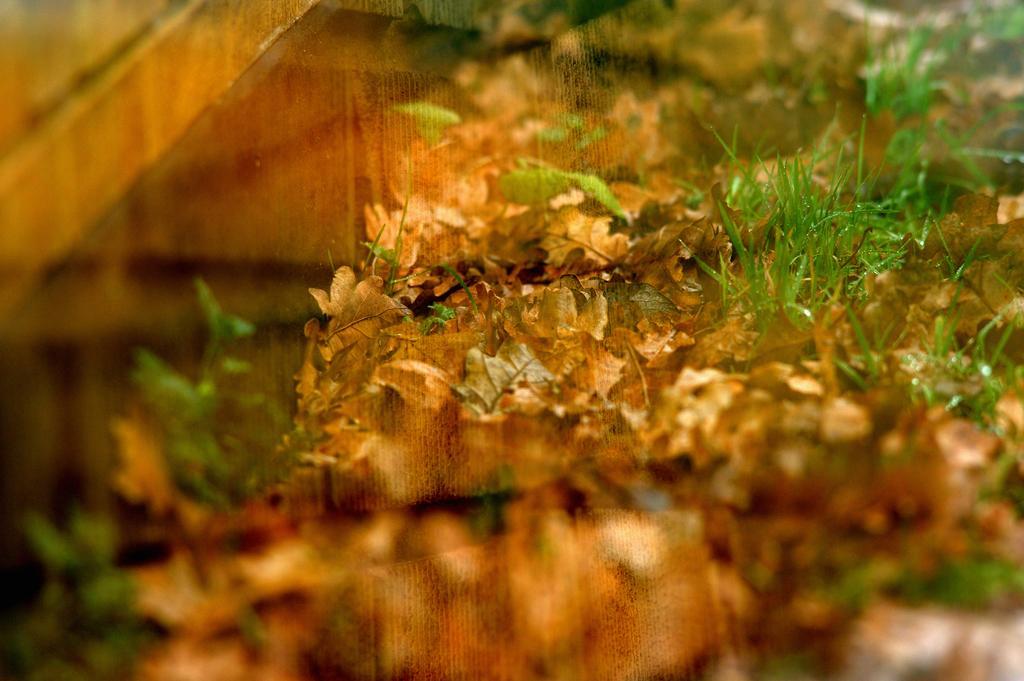Please provide a concise description of this image. It looks like a glass and on the glass we can see the reflection of grass and dry leaves. 